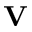<formula> <loc_0><loc_0><loc_500><loc_500>V</formula> 